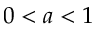Convert formula to latex. <formula><loc_0><loc_0><loc_500><loc_500>0 < a < 1</formula> 